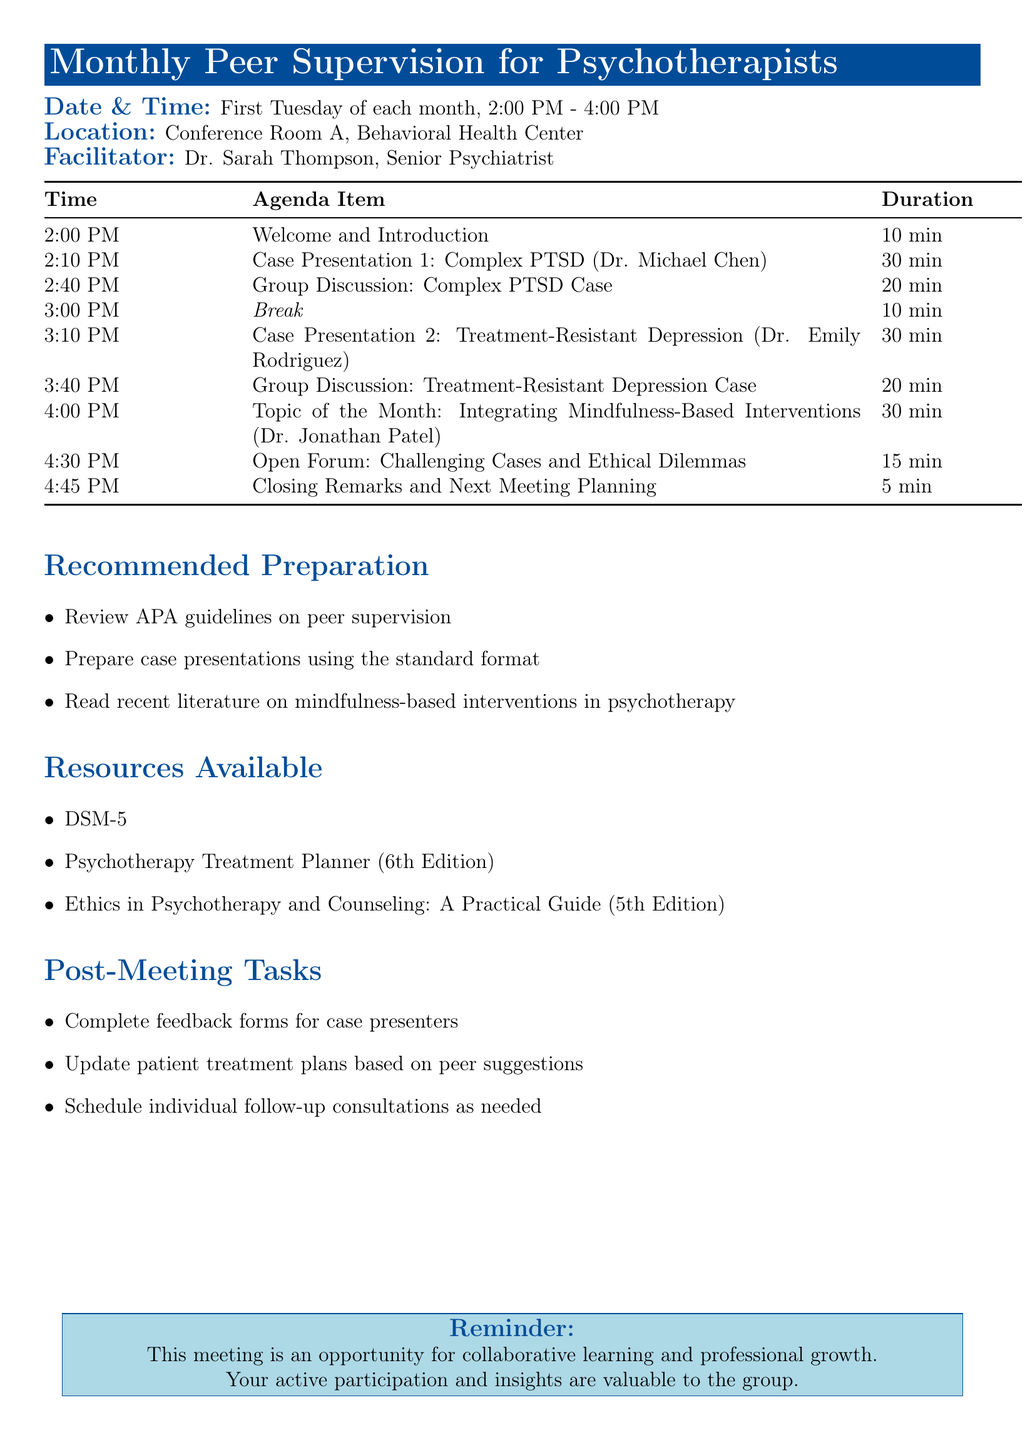What is the meeting title? The meeting title is explicitly stated at the beginning of the document.
Answer: Monthly Peer Supervision for Psychotherapists Who is the facilitator of the meeting? The document specifies the facilitator's name in the introductory section.
Answer: Dr. Sarah Thompson What is the duration of the first case presentation? The duration for each agenda item is listed clearly in the table.
Answer: 30 minutes When does the meeting take place? The meeting's date and time are provided in a dedicated segment.
Answer: First Tuesday of each month, 2:00 PM - 4:00 PM What is the topic of the month? The document highlights this topic under a distinct agenda item.
Answer: Integrating Mindfulness-Based Interventions How long is the scheduled lunch break? The break duration is mentioned in the agenda table.
Answer: 10 minutes What is one resource available for attendees? The resources available are listed in a specific section of the document.
Answer: DSM-5 What is the purpose of the open forum segment? The purpose of the segment is outlined in the agenda description for that item.
Answer: Opportunity for attendees to briefly present challenging cases or ethical dilemmas for group input What needs to be completed after the meeting? The post-meeting tasks are specified at the end of the agenda.
Answer: Complete feedback forms for case presenters 